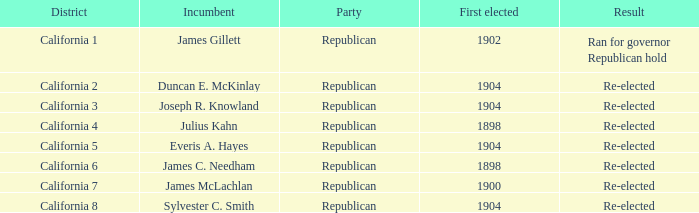Which sitting representative holds a district of california 5 position? Everis A. Hayes. 